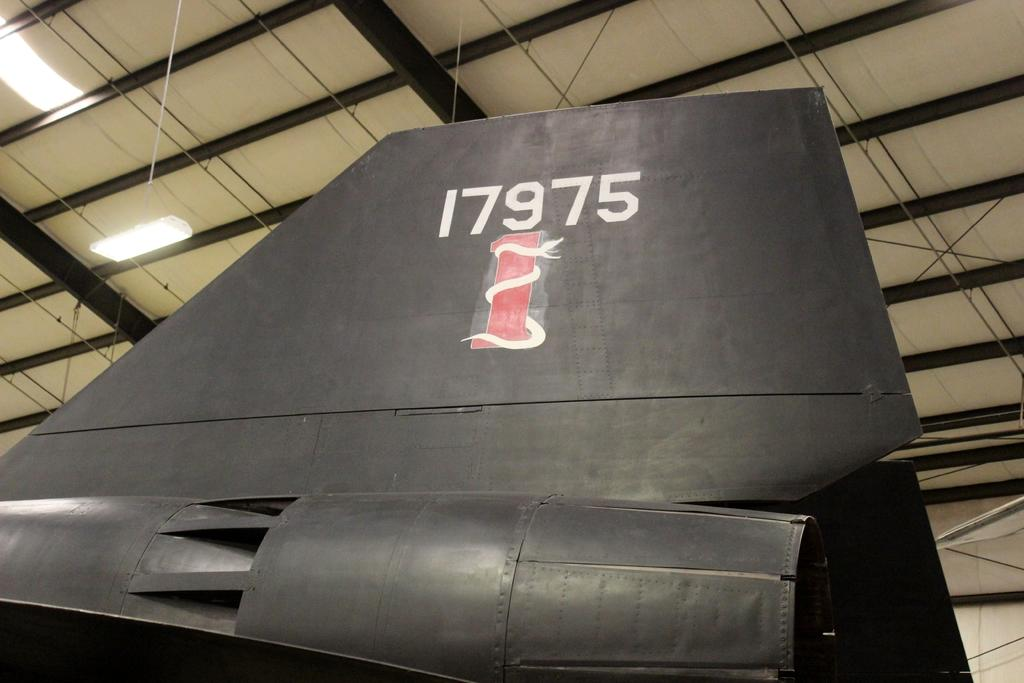Provide a one-sentence caption for the provided image. A snake is slithering along a red pole beneath the numbers 17975 on the rudder. 